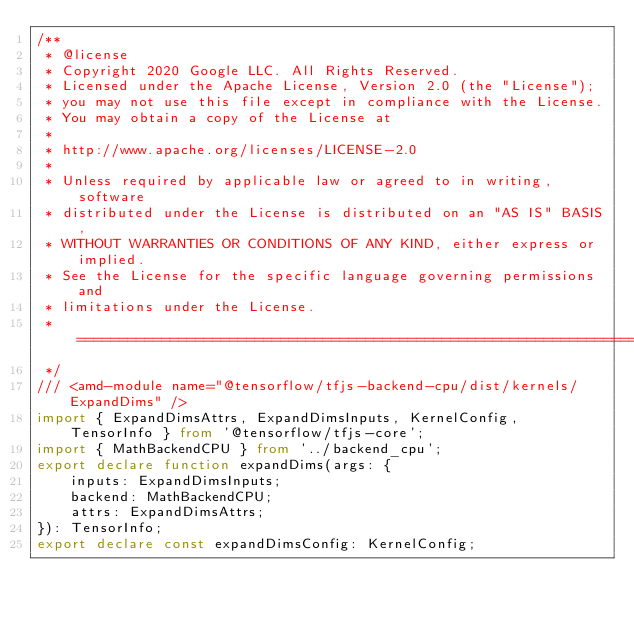<code> <loc_0><loc_0><loc_500><loc_500><_TypeScript_>/**
 * @license
 * Copyright 2020 Google LLC. All Rights Reserved.
 * Licensed under the Apache License, Version 2.0 (the "License");
 * you may not use this file except in compliance with the License.
 * You may obtain a copy of the License at
 *
 * http://www.apache.org/licenses/LICENSE-2.0
 *
 * Unless required by applicable law or agreed to in writing, software
 * distributed under the License is distributed on an "AS IS" BASIS,
 * WITHOUT WARRANTIES OR CONDITIONS OF ANY KIND, either express or implied.
 * See the License for the specific language governing permissions and
 * limitations under the License.
 * =============================================================================
 */
/// <amd-module name="@tensorflow/tfjs-backend-cpu/dist/kernels/ExpandDims" />
import { ExpandDimsAttrs, ExpandDimsInputs, KernelConfig, TensorInfo } from '@tensorflow/tfjs-core';
import { MathBackendCPU } from '../backend_cpu';
export declare function expandDims(args: {
    inputs: ExpandDimsInputs;
    backend: MathBackendCPU;
    attrs: ExpandDimsAttrs;
}): TensorInfo;
export declare const expandDimsConfig: KernelConfig;
</code> 